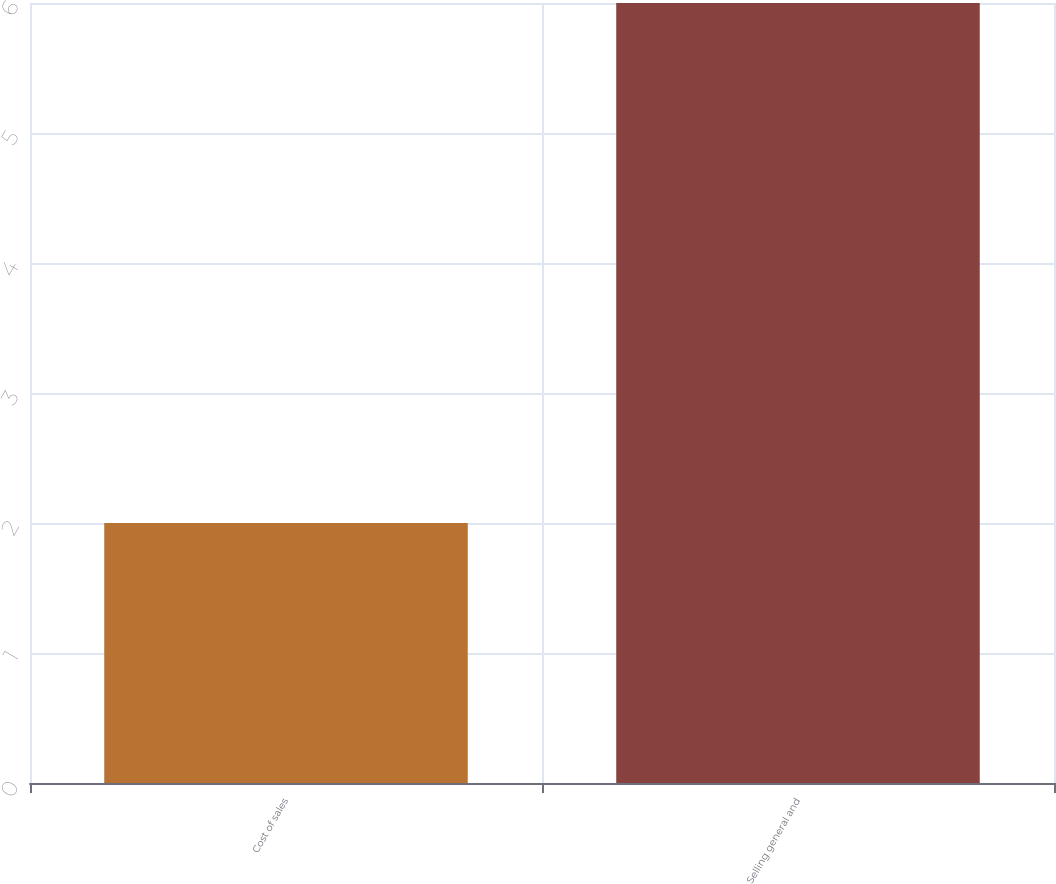Convert chart. <chart><loc_0><loc_0><loc_500><loc_500><bar_chart><fcel>Cost of sales<fcel>Selling general and<nl><fcel>2<fcel>6<nl></chart> 